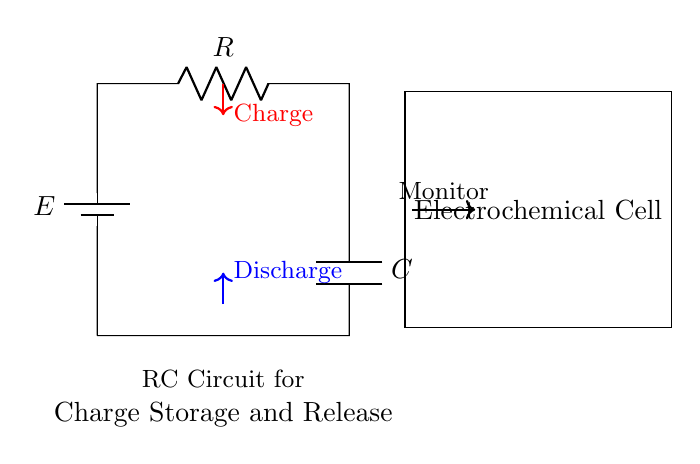What is the function of the battery in this circuit? The battery provides the necessary voltage for charging the capacitor. It acts as a source of electrical energy that drives current through the resistor and into the capacitor.
Answer: Voltage source What component is responsible for charge storage in the circuit? The capacitor is the component responsible for storing electrical charge by accumulating electrons on its plates when connected to the voltage source.
Answer: Capacitor How does the resistor affect the charging process? The resistor limits the amount of current that flows into the capacitor during the charging phase, controlling the rate at which the capacitor charges according to the time constant of the circuit.
Answer: Current limiter What happens to the charge when the circuit is disconnected? When the circuit is disconnected, the capacitor discharges its stored energy back into the circuit, providing a current flow until the stored charge is depleted.
Answer: Discharge What is the role of the monitoring unit next to the electrochemical cell? The monitoring unit observes the parameters of the electrochemical cell, likely measuring the charge state and performance metrics affected by both the resistor and the capacitor.
Answer: Observing parameters 